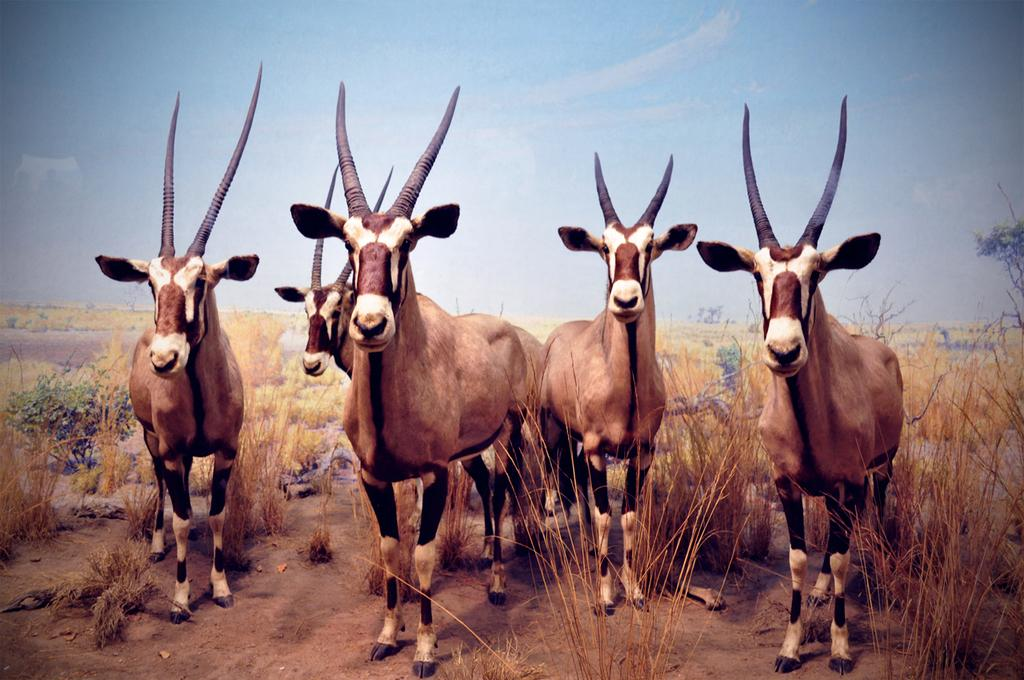What type of living organisms are present in the image? There are animals in the image. What colors can be seen on the animals? The animals have white, black, and brown colors. What type of vegetation is visible in the image? There is grass visible in the image. What is the condition of the sky in the background? The sky is clear in the background. What can be seen in the distance in the image? There is a tree in the background. How does the system increase the efficiency of the part in the image? There is no system or part mentioned in the image; it features animals, grass, and a tree. 